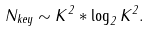Convert formula to latex. <formula><loc_0><loc_0><loc_500><loc_500>N _ { k e y } \sim K ^ { 2 } * \log _ { 2 } { K ^ { 2 } } .</formula> 